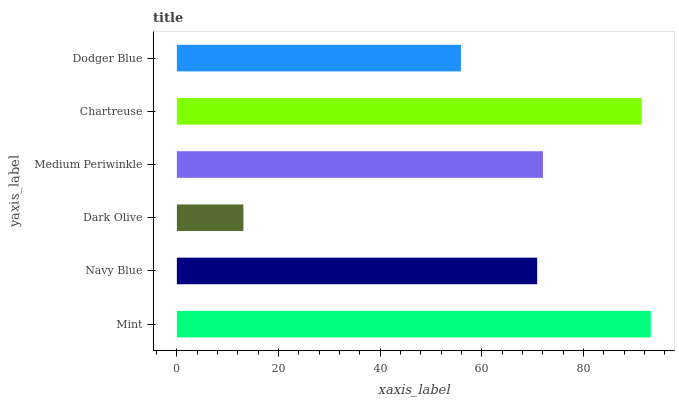Is Dark Olive the minimum?
Answer yes or no. Yes. Is Mint the maximum?
Answer yes or no. Yes. Is Navy Blue the minimum?
Answer yes or no. No. Is Navy Blue the maximum?
Answer yes or no. No. Is Mint greater than Navy Blue?
Answer yes or no. Yes. Is Navy Blue less than Mint?
Answer yes or no. Yes. Is Navy Blue greater than Mint?
Answer yes or no. No. Is Mint less than Navy Blue?
Answer yes or no. No. Is Medium Periwinkle the high median?
Answer yes or no. Yes. Is Navy Blue the low median?
Answer yes or no. Yes. Is Dark Olive the high median?
Answer yes or no. No. Is Mint the low median?
Answer yes or no. No. 